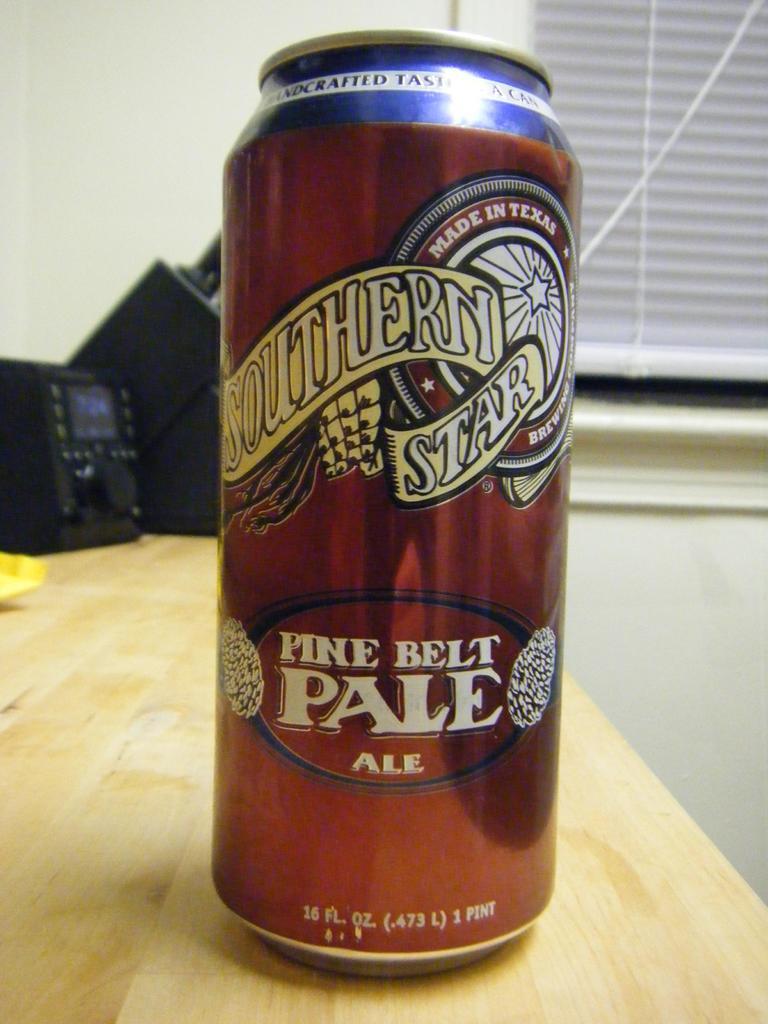What brand of ale is this?
Make the answer very short. Southern star. Where was this drink made?
Make the answer very short. Texas. 